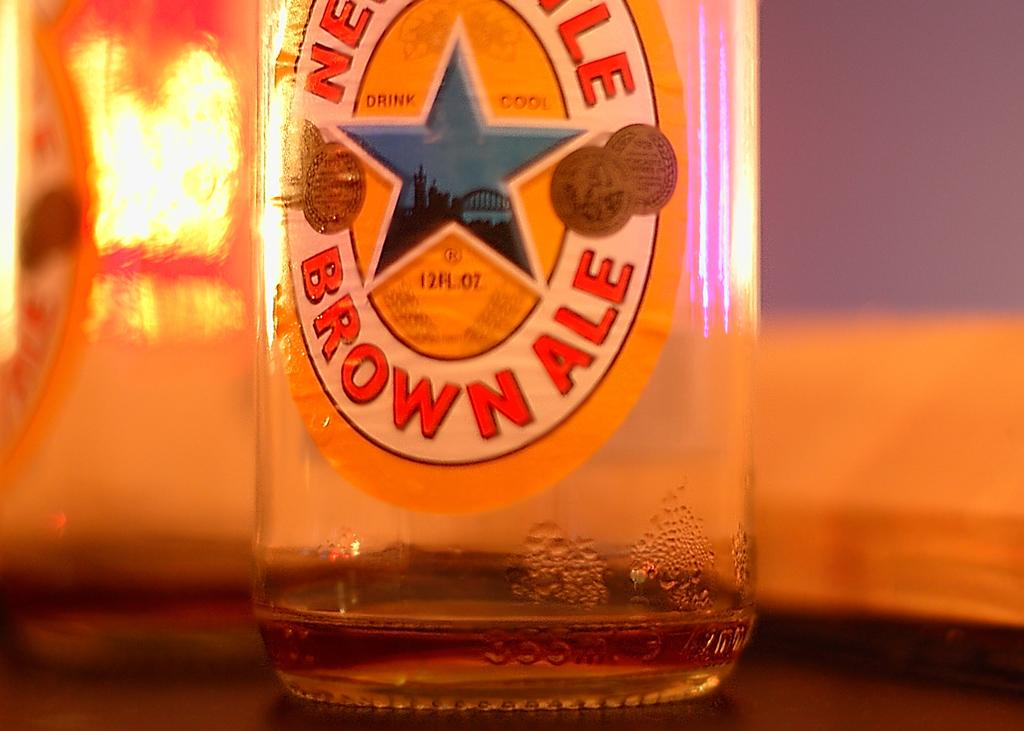What object is visible in the image that is made of glass? There is an empty glass bottle in the image. Where is the glass bottle located in the image? The glass bottle is placed on a table. What type of zipper is used to close the glass bottle in the image? There is no zipper present on the glass bottle in the image, as it is an empty bottle made of glass. 